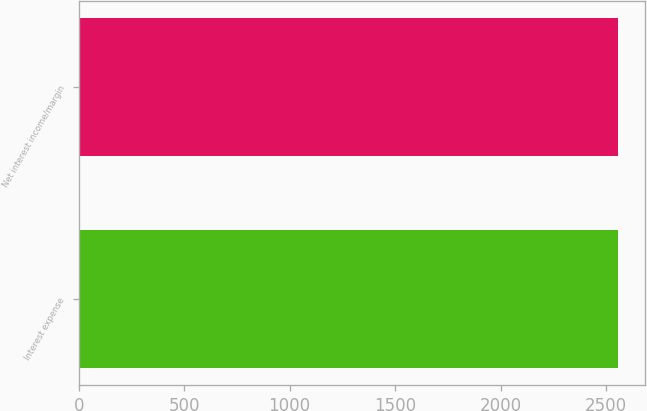Convert chart. <chart><loc_0><loc_0><loc_500><loc_500><bar_chart><fcel>Interest expense<fcel>Net interest income/margin<nl><fcel>2556<fcel>2556.1<nl></chart> 